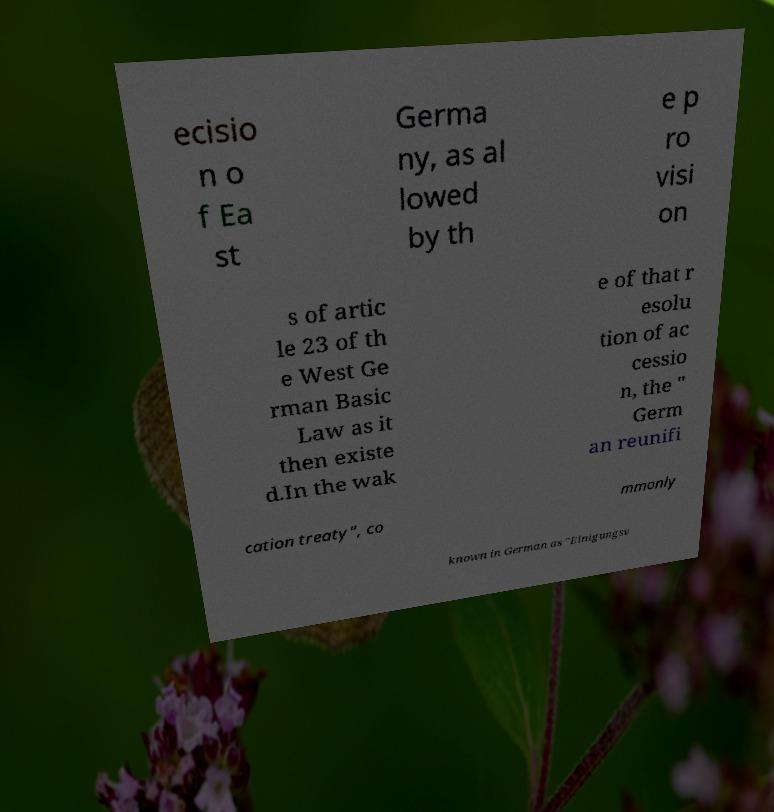I need the written content from this picture converted into text. Can you do that? ecisio n o f Ea st Germa ny, as al lowed by th e p ro visi on s of artic le 23 of th e West Ge rman Basic Law as it then existe d.In the wak e of that r esolu tion of ac cessio n, the " Germ an reunifi cation treaty", co mmonly known in German as "Einigungsv 